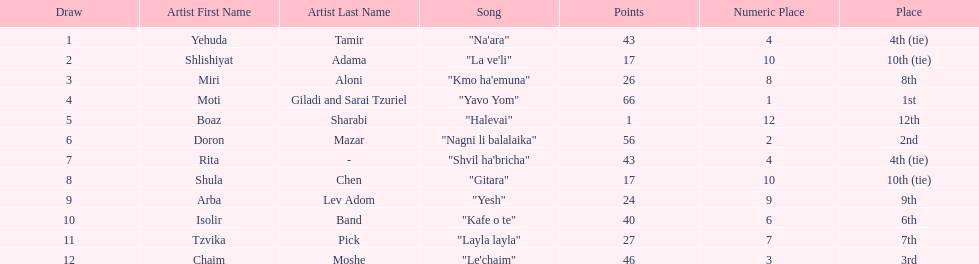Compare draws, which had the least amount of points? Boaz Sharabi. 